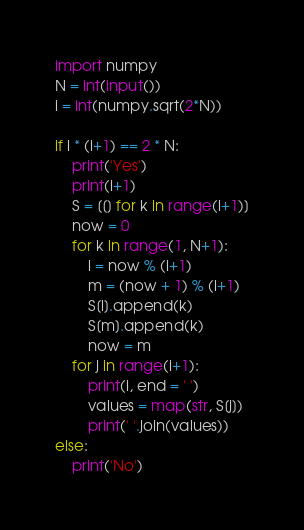Convert code to text. <code><loc_0><loc_0><loc_500><loc_500><_Python_>import numpy
N = int(input())
i = int(numpy.sqrt(2*N))

if i * (i+1) == 2 * N:
    print('Yes')
    print(i+1)
    S = [[] for k in range(i+1)]
    now = 0
    for k in range(1, N+1):
        l = now % (i+1)
        m = (now + 1) % (i+1)
        S[l].append(k)
        S[m].append(k)
        now = m
    for j in range(i+1):
        print(i, end = ' ')
        values = map(str, S[j])
        print(' '.join(values))
else:
    print('No')
</code> 